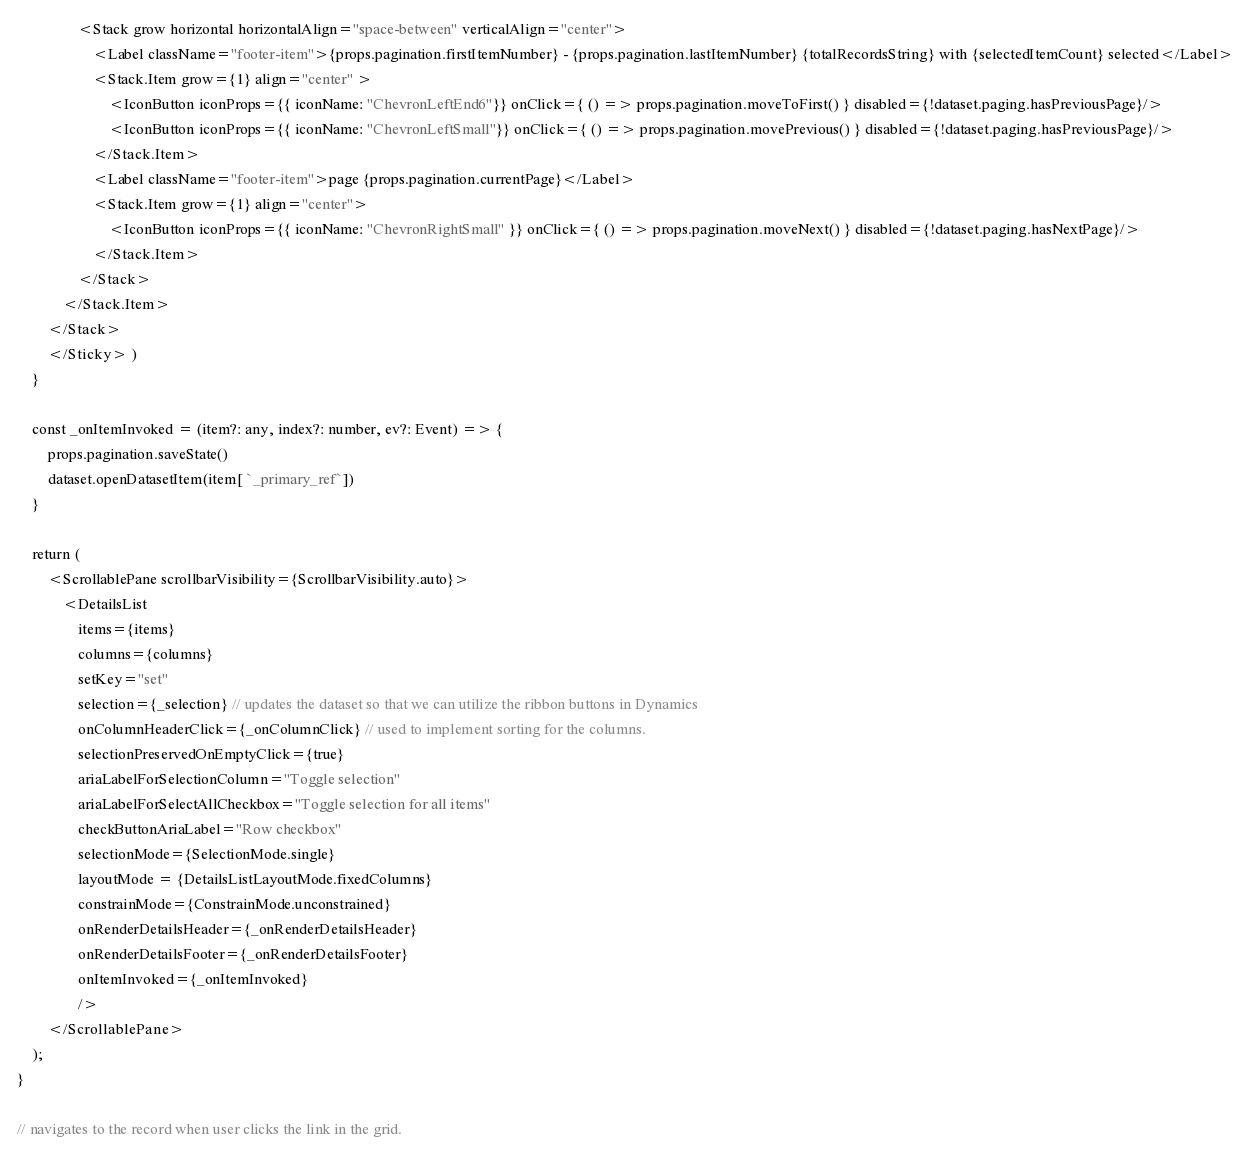Convert code to text. <code><loc_0><loc_0><loc_500><loc_500><_TypeScript_>                <Stack grow horizontal horizontalAlign="space-between" verticalAlign="center">
                    <Label className="footer-item">{props.pagination.firstItemNumber} - {props.pagination.lastItemNumber} {totalRecordsString} with {selectedItemCount} selected</Label>
                    <Stack.Item grow={1} align="center" >
                        <IconButton iconProps={{ iconName: "ChevronLeftEnd6"}} onClick={ () => props.pagination.moveToFirst() } disabled={!dataset.paging.hasPreviousPage}/>
                        <IconButton iconProps={{ iconName: "ChevronLeftSmall"}} onClick={ () => props.pagination.movePrevious() } disabled={!dataset.paging.hasPreviousPage}/>
                    </Stack.Item>
                    <Label className="footer-item">page {props.pagination.currentPage}</Label>
                    <Stack.Item grow={1} align="center">
                        <IconButton iconProps={{ iconName: "ChevronRightSmall" }} onClick={ () => props.pagination.moveNext() } disabled={!dataset.paging.hasNextPage}/>
                    </Stack.Item>
                </Stack>
            </Stack.Item>
        </Stack> 
        </Sticky> )
    }
      
    const _onItemInvoked = (item?: any, index?: number, ev?: Event) => {
        props.pagination.saveState()
        dataset.openDatasetItem(item[ `_primary_ref`])
    }

    return (   
        <ScrollablePane scrollbarVisibility={ScrollbarVisibility.auto}>
            <DetailsList                
                items={items}
                columns={columns}
                setKey="set"                                                                                         
                selection={_selection} // updates the dataset so that we can utilize the ribbon buttons in Dynamics                                        
                onColumnHeaderClick={_onColumnClick} // used to implement sorting for the columns.                    
                selectionPreservedOnEmptyClick={true}
                ariaLabelForSelectionColumn="Toggle selection"
                ariaLabelForSelectAllCheckbox="Toggle selection for all items"
                checkButtonAriaLabel="Row checkbox"                        
                selectionMode={SelectionMode.single}
                layoutMode = {DetailsListLayoutMode.fixedColumns}
                constrainMode={ConstrainMode.unconstrained}
                onRenderDetailsHeader={_onRenderDetailsHeader}
                onRenderDetailsFooter={_onRenderDetailsFooter}
                onItemInvoked={_onItemInvoked}
                />               
        </ScrollablePane>
    );
}

// navigates to the record when user clicks the link in the grid.</code> 